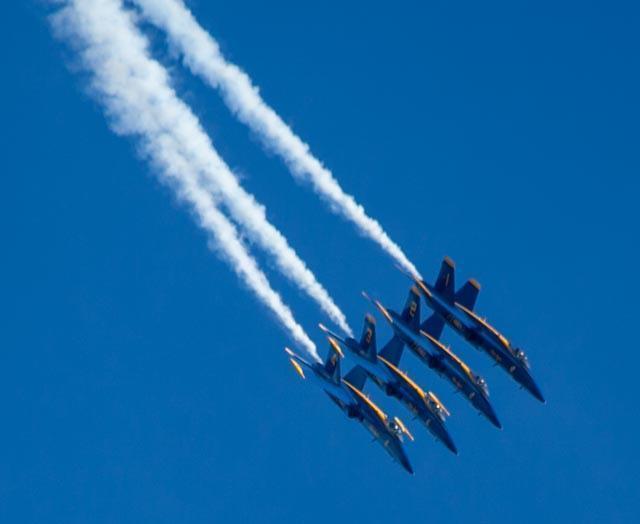How many planes do you see?
Give a very brief answer. 4. How many airplanes are visible?
Give a very brief answer. 4. How many sheep are there?
Give a very brief answer. 0. 